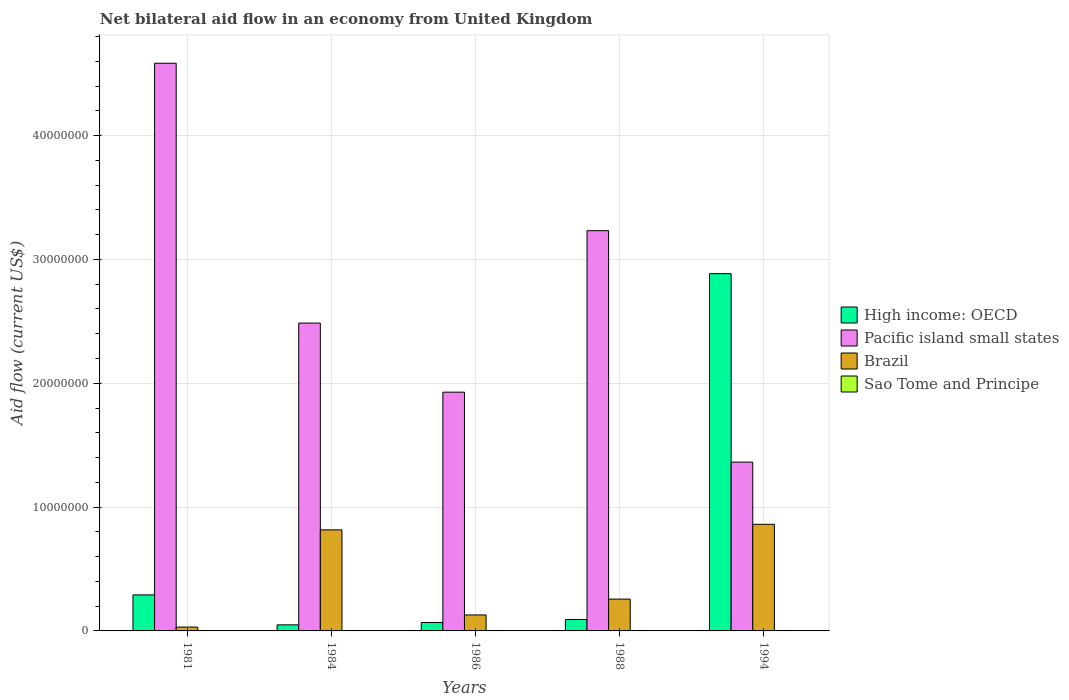How many different coloured bars are there?
Your answer should be compact. 4. How many groups of bars are there?
Provide a short and direct response. 5. Are the number of bars on each tick of the X-axis equal?
Keep it short and to the point. Yes. How many bars are there on the 5th tick from the right?
Keep it short and to the point. 4. What is the label of the 4th group of bars from the left?
Your response must be concise. 1988. In how many cases, is the number of bars for a given year not equal to the number of legend labels?
Give a very brief answer. 0. What is the net bilateral aid flow in High income: OECD in 1984?
Your answer should be compact. 4.90e+05. Across all years, what is the maximum net bilateral aid flow in High income: OECD?
Keep it short and to the point. 2.88e+07. Across all years, what is the minimum net bilateral aid flow in High income: OECD?
Your response must be concise. 4.90e+05. In which year was the net bilateral aid flow in Sao Tome and Principe minimum?
Provide a short and direct response. 1981. What is the total net bilateral aid flow in Pacific island small states in the graph?
Your answer should be compact. 1.36e+08. What is the difference between the net bilateral aid flow in Brazil in 1981 and that in 1988?
Offer a very short reply. -2.26e+06. What is the difference between the net bilateral aid flow in High income: OECD in 1981 and the net bilateral aid flow in Pacific island small states in 1984?
Give a very brief answer. -2.20e+07. What is the average net bilateral aid flow in High income: OECD per year?
Ensure brevity in your answer.  6.77e+06. In the year 1981, what is the difference between the net bilateral aid flow in Sao Tome and Principe and net bilateral aid flow in High income: OECD?
Give a very brief answer. -2.90e+06. In how many years, is the net bilateral aid flow in Brazil greater than 44000000 US$?
Offer a very short reply. 0. What is the ratio of the net bilateral aid flow in Brazil in 1988 to that in 1994?
Offer a very short reply. 0.3. Is the net bilateral aid flow in Sao Tome and Principe in 1981 less than that in 1986?
Make the answer very short. No. What is the difference between the highest and the second highest net bilateral aid flow in Pacific island small states?
Offer a terse response. 1.35e+07. What is the difference between the highest and the lowest net bilateral aid flow in Sao Tome and Principe?
Keep it short and to the point. 2.00e+04. Is it the case that in every year, the sum of the net bilateral aid flow in High income: OECD and net bilateral aid flow in Pacific island small states is greater than the sum of net bilateral aid flow in Brazil and net bilateral aid flow in Sao Tome and Principe?
Offer a very short reply. Yes. What does the 1st bar from the left in 1988 represents?
Ensure brevity in your answer.  High income: OECD. What does the 4th bar from the right in 1994 represents?
Offer a terse response. High income: OECD. Are all the bars in the graph horizontal?
Give a very brief answer. No. Does the graph contain grids?
Provide a short and direct response. Yes. How are the legend labels stacked?
Provide a succinct answer. Vertical. What is the title of the graph?
Keep it short and to the point. Net bilateral aid flow in an economy from United Kingdom. What is the label or title of the X-axis?
Offer a terse response. Years. What is the label or title of the Y-axis?
Provide a short and direct response. Aid flow (current US$). What is the Aid flow (current US$) in High income: OECD in 1981?
Give a very brief answer. 2.91e+06. What is the Aid flow (current US$) of Pacific island small states in 1981?
Offer a very short reply. 4.58e+07. What is the Aid flow (current US$) in Sao Tome and Principe in 1981?
Your answer should be compact. 10000. What is the Aid flow (current US$) in Pacific island small states in 1984?
Keep it short and to the point. 2.49e+07. What is the Aid flow (current US$) of Brazil in 1984?
Give a very brief answer. 8.16e+06. What is the Aid flow (current US$) of High income: OECD in 1986?
Your response must be concise. 6.80e+05. What is the Aid flow (current US$) of Pacific island small states in 1986?
Ensure brevity in your answer.  1.93e+07. What is the Aid flow (current US$) of Brazil in 1986?
Your response must be concise. 1.29e+06. What is the Aid flow (current US$) of High income: OECD in 1988?
Your answer should be compact. 9.20e+05. What is the Aid flow (current US$) in Pacific island small states in 1988?
Ensure brevity in your answer.  3.23e+07. What is the Aid flow (current US$) of Brazil in 1988?
Make the answer very short. 2.57e+06. What is the Aid flow (current US$) of High income: OECD in 1994?
Your answer should be very brief. 2.88e+07. What is the Aid flow (current US$) of Pacific island small states in 1994?
Your answer should be compact. 1.36e+07. What is the Aid flow (current US$) in Brazil in 1994?
Give a very brief answer. 8.61e+06. What is the Aid flow (current US$) of Sao Tome and Principe in 1994?
Make the answer very short. 10000. Across all years, what is the maximum Aid flow (current US$) in High income: OECD?
Provide a succinct answer. 2.88e+07. Across all years, what is the maximum Aid flow (current US$) in Pacific island small states?
Give a very brief answer. 4.58e+07. Across all years, what is the maximum Aid flow (current US$) in Brazil?
Give a very brief answer. 8.61e+06. Across all years, what is the minimum Aid flow (current US$) in Pacific island small states?
Your answer should be compact. 1.36e+07. What is the total Aid flow (current US$) of High income: OECD in the graph?
Ensure brevity in your answer.  3.38e+07. What is the total Aid flow (current US$) of Pacific island small states in the graph?
Your response must be concise. 1.36e+08. What is the total Aid flow (current US$) in Brazil in the graph?
Give a very brief answer. 2.09e+07. What is the total Aid flow (current US$) of Sao Tome and Principe in the graph?
Make the answer very short. 9.00e+04. What is the difference between the Aid flow (current US$) of High income: OECD in 1981 and that in 1984?
Your answer should be compact. 2.42e+06. What is the difference between the Aid flow (current US$) in Pacific island small states in 1981 and that in 1984?
Offer a terse response. 2.10e+07. What is the difference between the Aid flow (current US$) of Brazil in 1981 and that in 1984?
Provide a succinct answer. -7.85e+06. What is the difference between the Aid flow (current US$) in High income: OECD in 1981 and that in 1986?
Your answer should be very brief. 2.23e+06. What is the difference between the Aid flow (current US$) in Pacific island small states in 1981 and that in 1986?
Give a very brief answer. 2.66e+07. What is the difference between the Aid flow (current US$) in Brazil in 1981 and that in 1986?
Make the answer very short. -9.80e+05. What is the difference between the Aid flow (current US$) in High income: OECD in 1981 and that in 1988?
Give a very brief answer. 1.99e+06. What is the difference between the Aid flow (current US$) in Pacific island small states in 1981 and that in 1988?
Your response must be concise. 1.35e+07. What is the difference between the Aid flow (current US$) of Brazil in 1981 and that in 1988?
Your response must be concise. -2.26e+06. What is the difference between the Aid flow (current US$) in High income: OECD in 1981 and that in 1994?
Your answer should be compact. -2.59e+07. What is the difference between the Aid flow (current US$) in Pacific island small states in 1981 and that in 1994?
Your answer should be very brief. 3.22e+07. What is the difference between the Aid flow (current US$) of Brazil in 1981 and that in 1994?
Offer a terse response. -8.30e+06. What is the difference between the Aid flow (current US$) in High income: OECD in 1984 and that in 1986?
Offer a terse response. -1.90e+05. What is the difference between the Aid flow (current US$) in Pacific island small states in 1984 and that in 1986?
Provide a short and direct response. 5.58e+06. What is the difference between the Aid flow (current US$) of Brazil in 1984 and that in 1986?
Keep it short and to the point. 6.87e+06. What is the difference between the Aid flow (current US$) of High income: OECD in 1984 and that in 1988?
Your answer should be compact. -4.30e+05. What is the difference between the Aid flow (current US$) in Pacific island small states in 1984 and that in 1988?
Make the answer very short. -7.46e+06. What is the difference between the Aid flow (current US$) in Brazil in 1984 and that in 1988?
Your answer should be very brief. 5.59e+06. What is the difference between the Aid flow (current US$) of High income: OECD in 1984 and that in 1994?
Keep it short and to the point. -2.84e+07. What is the difference between the Aid flow (current US$) in Pacific island small states in 1984 and that in 1994?
Keep it short and to the point. 1.12e+07. What is the difference between the Aid flow (current US$) in Brazil in 1984 and that in 1994?
Provide a short and direct response. -4.50e+05. What is the difference between the Aid flow (current US$) in Sao Tome and Principe in 1984 and that in 1994?
Offer a terse response. 2.00e+04. What is the difference between the Aid flow (current US$) in Pacific island small states in 1986 and that in 1988?
Make the answer very short. -1.30e+07. What is the difference between the Aid flow (current US$) of Brazil in 1986 and that in 1988?
Keep it short and to the point. -1.28e+06. What is the difference between the Aid flow (current US$) in High income: OECD in 1986 and that in 1994?
Provide a short and direct response. -2.82e+07. What is the difference between the Aid flow (current US$) of Pacific island small states in 1986 and that in 1994?
Ensure brevity in your answer.  5.65e+06. What is the difference between the Aid flow (current US$) of Brazil in 1986 and that in 1994?
Your answer should be compact. -7.32e+06. What is the difference between the Aid flow (current US$) in High income: OECD in 1988 and that in 1994?
Your answer should be very brief. -2.79e+07. What is the difference between the Aid flow (current US$) in Pacific island small states in 1988 and that in 1994?
Offer a very short reply. 1.87e+07. What is the difference between the Aid flow (current US$) in Brazil in 1988 and that in 1994?
Offer a very short reply. -6.04e+06. What is the difference between the Aid flow (current US$) in Sao Tome and Principe in 1988 and that in 1994?
Your answer should be very brief. 2.00e+04. What is the difference between the Aid flow (current US$) in High income: OECD in 1981 and the Aid flow (current US$) in Pacific island small states in 1984?
Provide a succinct answer. -2.20e+07. What is the difference between the Aid flow (current US$) of High income: OECD in 1981 and the Aid flow (current US$) of Brazil in 1984?
Your response must be concise. -5.25e+06. What is the difference between the Aid flow (current US$) of High income: OECD in 1981 and the Aid flow (current US$) of Sao Tome and Principe in 1984?
Keep it short and to the point. 2.88e+06. What is the difference between the Aid flow (current US$) in Pacific island small states in 1981 and the Aid flow (current US$) in Brazil in 1984?
Your answer should be compact. 3.77e+07. What is the difference between the Aid flow (current US$) of Pacific island small states in 1981 and the Aid flow (current US$) of Sao Tome and Principe in 1984?
Your response must be concise. 4.58e+07. What is the difference between the Aid flow (current US$) in High income: OECD in 1981 and the Aid flow (current US$) in Pacific island small states in 1986?
Make the answer very short. -1.64e+07. What is the difference between the Aid flow (current US$) of High income: OECD in 1981 and the Aid flow (current US$) of Brazil in 1986?
Offer a terse response. 1.62e+06. What is the difference between the Aid flow (current US$) of High income: OECD in 1981 and the Aid flow (current US$) of Sao Tome and Principe in 1986?
Provide a succinct answer. 2.90e+06. What is the difference between the Aid flow (current US$) in Pacific island small states in 1981 and the Aid flow (current US$) in Brazil in 1986?
Keep it short and to the point. 4.46e+07. What is the difference between the Aid flow (current US$) of Pacific island small states in 1981 and the Aid flow (current US$) of Sao Tome and Principe in 1986?
Make the answer very short. 4.58e+07. What is the difference between the Aid flow (current US$) of High income: OECD in 1981 and the Aid flow (current US$) of Pacific island small states in 1988?
Make the answer very short. -2.94e+07. What is the difference between the Aid flow (current US$) of High income: OECD in 1981 and the Aid flow (current US$) of Sao Tome and Principe in 1988?
Give a very brief answer. 2.88e+06. What is the difference between the Aid flow (current US$) of Pacific island small states in 1981 and the Aid flow (current US$) of Brazil in 1988?
Your answer should be compact. 4.33e+07. What is the difference between the Aid flow (current US$) of Pacific island small states in 1981 and the Aid flow (current US$) of Sao Tome and Principe in 1988?
Offer a terse response. 4.58e+07. What is the difference between the Aid flow (current US$) in Brazil in 1981 and the Aid flow (current US$) in Sao Tome and Principe in 1988?
Your response must be concise. 2.80e+05. What is the difference between the Aid flow (current US$) in High income: OECD in 1981 and the Aid flow (current US$) in Pacific island small states in 1994?
Provide a succinct answer. -1.07e+07. What is the difference between the Aid flow (current US$) in High income: OECD in 1981 and the Aid flow (current US$) in Brazil in 1994?
Provide a short and direct response. -5.70e+06. What is the difference between the Aid flow (current US$) in High income: OECD in 1981 and the Aid flow (current US$) in Sao Tome and Principe in 1994?
Provide a short and direct response. 2.90e+06. What is the difference between the Aid flow (current US$) of Pacific island small states in 1981 and the Aid flow (current US$) of Brazil in 1994?
Make the answer very short. 3.72e+07. What is the difference between the Aid flow (current US$) of Pacific island small states in 1981 and the Aid flow (current US$) of Sao Tome and Principe in 1994?
Your response must be concise. 4.58e+07. What is the difference between the Aid flow (current US$) in Brazil in 1981 and the Aid flow (current US$) in Sao Tome and Principe in 1994?
Keep it short and to the point. 3.00e+05. What is the difference between the Aid flow (current US$) in High income: OECD in 1984 and the Aid flow (current US$) in Pacific island small states in 1986?
Offer a terse response. -1.88e+07. What is the difference between the Aid flow (current US$) of High income: OECD in 1984 and the Aid flow (current US$) of Brazil in 1986?
Offer a very short reply. -8.00e+05. What is the difference between the Aid flow (current US$) of Pacific island small states in 1984 and the Aid flow (current US$) of Brazil in 1986?
Ensure brevity in your answer.  2.36e+07. What is the difference between the Aid flow (current US$) in Pacific island small states in 1984 and the Aid flow (current US$) in Sao Tome and Principe in 1986?
Provide a short and direct response. 2.48e+07. What is the difference between the Aid flow (current US$) of Brazil in 1984 and the Aid flow (current US$) of Sao Tome and Principe in 1986?
Offer a terse response. 8.15e+06. What is the difference between the Aid flow (current US$) of High income: OECD in 1984 and the Aid flow (current US$) of Pacific island small states in 1988?
Keep it short and to the point. -3.18e+07. What is the difference between the Aid flow (current US$) of High income: OECD in 1984 and the Aid flow (current US$) of Brazil in 1988?
Give a very brief answer. -2.08e+06. What is the difference between the Aid flow (current US$) of High income: OECD in 1984 and the Aid flow (current US$) of Sao Tome and Principe in 1988?
Your answer should be very brief. 4.60e+05. What is the difference between the Aid flow (current US$) of Pacific island small states in 1984 and the Aid flow (current US$) of Brazil in 1988?
Your answer should be compact. 2.23e+07. What is the difference between the Aid flow (current US$) of Pacific island small states in 1984 and the Aid flow (current US$) of Sao Tome and Principe in 1988?
Your answer should be compact. 2.48e+07. What is the difference between the Aid flow (current US$) in Brazil in 1984 and the Aid flow (current US$) in Sao Tome and Principe in 1988?
Ensure brevity in your answer.  8.13e+06. What is the difference between the Aid flow (current US$) in High income: OECD in 1984 and the Aid flow (current US$) in Pacific island small states in 1994?
Give a very brief answer. -1.31e+07. What is the difference between the Aid flow (current US$) in High income: OECD in 1984 and the Aid flow (current US$) in Brazil in 1994?
Ensure brevity in your answer.  -8.12e+06. What is the difference between the Aid flow (current US$) of Pacific island small states in 1984 and the Aid flow (current US$) of Brazil in 1994?
Your answer should be compact. 1.62e+07. What is the difference between the Aid flow (current US$) in Pacific island small states in 1984 and the Aid flow (current US$) in Sao Tome and Principe in 1994?
Your answer should be very brief. 2.48e+07. What is the difference between the Aid flow (current US$) in Brazil in 1984 and the Aid flow (current US$) in Sao Tome and Principe in 1994?
Your response must be concise. 8.15e+06. What is the difference between the Aid flow (current US$) of High income: OECD in 1986 and the Aid flow (current US$) of Pacific island small states in 1988?
Make the answer very short. -3.16e+07. What is the difference between the Aid flow (current US$) in High income: OECD in 1986 and the Aid flow (current US$) in Brazil in 1988?
Provide a succinct answer. -1.89e+06. What is the difference between the Aid flow (current US$) in High income: OECD in 1986 and the Aid flow (current US$) in Sao Tome and Principe in 1988?
Make the answer very short. 6.50e+05. What is the difference between the Aid flow (current US$) of Pacific island small states in 1986 and the Aid flow (current US$) of Brazil in 1988?
Keep it short and to the point. 1.67e+07. What is the difference between the Aid flow (current US$) in Pacific island small states in 1986 and the Aid flow (current US$) in Sao Tome and Principe in 1988?
Offer a terse response. 1.92e+07. What is the difference between the Aid flow (current US$) in Brazil in 1986 and the Aid flow (current US$) in Sao Tome and Principe in 1988?
Your response must be concise. 1.26e+06. What is the difference between the Aid flow (current US$) of High income: OECD in 1986 and the Aid flow (current US$) of Pacific island small states in 1994?
Make the answer very short. -1.30e+07. What is the difference between the Aid flow (current US$) in High income: OECD in 1986 and the Aid flow (current US$) in Brazil in 1994?
Keep it short and to the point. -7.93e+06. What is the difference between the Aid flow (current US$) in High income: OECD in 1986 and the Aid flow (current US$) in Sao Tome and Principe in 1994?
Provide a succinct answer. 6.70e+05. What is the difference between the Aid flow (current US$) of Pacific island small states in 1986 and the Aid flow (current US$) of Brazil in 1994?
Make the answer very short. 1.07e+07. What is the difference between the Aid flow (current US$) of Pacific island small states in 1986 and the Aid flow (current US$) of Sao Tome and Principe in 1994?
Make the answer very short. 1.93e+07. What is the difference between the Aid flow (current US$) in Brazil in 1986 and the Aid flow (current US$) in Sao Tome and Principe in 1994?
Your answer should be very brief. 1.28e+06. What is the difference between the Aid flow (current US$) in High income: OECD in 1988 and the Aid flow (current US$) in Pacific island small states in 1994?
Make the answer very short. -1.27e+07. What is the difference between the Aid flow (current US$) of High income: OECD in 1988 and the Aid flow (current US$) of Brazil in 1994?
Provide a succinct answer. -7.69e+06. What is the difference between the Aid flow (current US$) of High income: OECD in 1988 and the Aid flow (current US$) of Sao Tome and Principe in 1994?
Your response must be concise. 9.10e+05. What is the difference between the Aid flow (current US$) in Pacific island small states in 1988 and the Aid flow (current US$) in Brazil in 1994?
Provide a succinct answer. 2.37e+07. What is the difference between the Aid flow (current US$) of Pacific island small states in 1988 and the Aid flow (current US$) of Sao Tome and Principe in 1994?
Your response must be concise. 3.23e+07. What is the difference between the Aid flow (current US$) in Brazil in 1988 and the Aid flow (current US$) in Sao Tome and Principe in 1994?
Offer a very short reply. 2.56e+06. What is the average Aid flow (current US$) in High income: OECD per year?
Offer a terse response. 6.77e+06. What is the average Aid flow (current US$) of Pacific island small states per year?
Keep it short and to the point. 2.72e+07. What is the average Aid flow (current US$) of Brazil per year?
Your response must be concise. 4.19e+06. What is the average Aid flow (current US$) of Sao Tome and Principe per year?
Offer a terse response. 1.80e+04. In the year 1981, what is the difference between the Aid flow (current US$) of High income: OECD and Aid flow (current US$) of Pacific island small states?
Provide a succinct answer. -4.29e+07. In the year 1981, what is the difference between the Aid flow (current US$) in High income: OECD and Aid flow (current US$) in Brazil?
Your answer should be compact. 2.60e+06. In the year 1981, what is the difference between the Aid flow (current US$) of High income: OECD and Aid flow (current US$) of Sao Tome and Principe?
Ensure brevity in your answer.  2.90e+06. In the year 1981, what is the difference between the Aid flow (current US$) in Pacific island small states and Aid flow (current US$) in Brazil?
Make the answer very short. 4.55e+07. In the year 1981, what is the difference between the Aid flow (current US$) of Pacific island small states and Aid flow (current US$) of Sao Tome and Principe?
Make the answer very short. 4.58e+07. In the year 1984, what is the difference between the Aid flow (current US$) of High income: OECD and Aid flow (current US$) of Pacific island small states?
Offer a very short reply. -2.44e+07. In the year 1984, what is the difference between the Aid flow (current US$) in High income: OECD and Aid flow (current US$) in Brazil?
Ensure brevity in your answer.  -7.67e+06. In the year 1984, what is the difference between the Aid flow (current US$) of Pacific island small states and Aid flow (current US$) of Brazil?
Your answer should be compact. 1.67e+07. In the year 1984, what is the difference between the Aid flow (current US$) in Pacific island small states and Aid flow (current US$) in Sao Tome and Principe?
Provide a succinct answer. 2.48e+07. In the year 1984, what is the difference between the Aid flow (current US$) in Brazil and Aid flow (current US$) in Sao Tome and Principe?
Provide a short and direct response. 8.13e+06. In the year 1986, what is the difference between the Aid flow (current US$) in High income: OECD and Aid flow (current US$) in Pacific island small states?
Offer a very short reply. -1.86e+07. In the year 1986, what is the difference between the Aid flow (current US$) in High income: OECD and Aid flow (current US$) in Brazil?
Offer a very short reply. -6.10e+05. In the year 1986, what is the difference between the Aid flow (current US$) in High income: OECD and Aid flow (current US$) in Sao Tome and Principe?
Your answer should be compact. 6.70e+05. In the year 1986, what is the difference between the Aid flow (current US$) of Pacific island small states and Aid flow (current US$) of Brazil?
Make the answer very short. 1.80e+07. In the year 1986, what is the difference between the Aid flow (current US$) of Pacific island small states and Aid flow (current US$) of Sao Tome and Principe?
Offer a very short reply. 1.93e+07. In the year 1986, what is the difference between the Aid flow (current US$) of Brazil and Aid flow (current US$) of Sao Tome and Principe?
Your response must be concise. 1.28e+06. In the year 1988, what is the difference between the Aid flow (current US$) in High income: OECD and Aid flow (current US$) in Pacific island small states?
Your answer should be compact. -3.14e+07. In the year 1988, what is the difference between the Aid flow (current US$) of High income: OECD and Aid flow (current US$) of Brazil?
Provide a short and direct response. -1.65e+06. In the year 1988, what is the difference between the Aid flow (current US$) of High income: OECD and Aid flow (current US$) of Sao Tome and Principe?
Offer a terse response. 8.90e+05. In the year 1988, what is the difference between the Aid flow (current US$) of Pacific island small states and Aid flow (current US$) of Brazil?
Give a very brief answer. 2.98e+07. In the year 1988, what is the difference between the Aid flow (current US$) in Pacific island small states and Aid flow (current US$) in Sao Tome and Principe?
Ensure brevity in your answer.  3.23e+07. In the year 1988, what is the difference between the Aid flow (current US$) of Brazil and Aid flow (current US$) of Sao Tome and Principe?
Your answer should be compact. 2.54e+06. In the year 1994, what is the difference between the Aid flow (current US$) of High income: OECD and Aid flow (current US$) of Pacific island small states?
Give a very brief answer. 1.52e+07. In the year 1994, what is the difference between the Aid flow (current US$) in High income: OECD and Aid flow (current US$) in Brazil?
Ensure brevity in your answer.  2.02e+07. In the year 1994, what is the difference between the Aid flow (current US$) in High income: OECD and Aid flow (current US$) in Sao Tome and Principe?
Your answer should be compact. 2.88e+07. In the year 1994, what is the difference between the Aid flow (current US$) in Pacific island small states and Aid flow (current US$) in Brazil?
Keep it short and to the point. 5.02e+06. In the year 1994, what is the difference between the Aid flow (current US$) in Pacific island small states and Aid flow (current US$) in Sao Tome and Principe?
Offer a terse response. 1.36e+07. In the year 1994, what is the difference between the Aid flow (current US$) of Brazil and Aid flow (current US$) of Sao Tome and Principe?
Your answer should be compact. 8.60e+06. What is the ratio of the Aid flow (current US$) in High income: OECD in 1981 to that in 1984?
Keep it short and to the point. 5.94. What is the ratio of the Aid flow (current US$) in Pacific island small states in 1981 to that in 1984?
Ensure brevity in your answer.  1.84. What is the ratio of the Aid flow (current US$) of Brazil in 1981 to that in 1984?
Provide a succinct answer. 0.04. What is the ratio of the Aid flow (current US$) in Sao Tome and Principe in 1981 to that in 1984?
Offer a very short reply. 0.33. What is the ratio of the Aid flow (current US$) in High income: OECD in 1981 to that in 1986?
Keep it short and to the point. 4.28. What is the ratio of the Aid flow (current US$) in Pacific island small states in 1981 to that in 1986?
Provide a short and direct response. 2.38. What is the ratio of the Aid flow (current US$) in Brazil in 1981 to that in 1986?
Provide a short and direct response. 0.24. What is the ratio of the Aid flow (current US$) in High income: OECD in 1981 to that in 1988?
Ensure brevity in your answer.  3.16. What is the ratio of the Aid flow (current US$) in Pacific island small states in 1981 to that in 1988?
Your answer should be compact. 1.42. What is the ratio of the Aid flow (current US$) in Brazil in 1981 to that in 1988?
Keep it short and to the point. 0.12. What is the ratio of the Aid flow (current US$) in Sao Tome and Principe in 1981 to that in 1988?
Offer a terse response. 0.33. What is the ratio of the Aid flow (current US$) in High income: OECD in 1981 to that in 1994?
Offer a terse response. 0.1. What is the ratio of the Aid flow (current US$) in Pacific island small states in 1981 to that in 1994?
Provide a succinct answer. 3.36. What is the ratio of the Aid flow (current US$) of Brazil in 1981 to that in 1994?
Ensure brevity in your answer.  0.04. What is the ratio of the Aid flow (current US$) in Sao Tome and Principe in 1981 to that in 1994?
Your answer should be very brief. 1. What is the ratio of the Aid flow (current US$) in High income: OECD in 1984 to that in 1986?
Your answer should be compact. 0.72. What is the ratio of the Aid flow (current US$) of Pacific island small states in 1984 to that in 1986?
Your answer should be very brief. 1.29. What is the ratio of the Aid flow (current US$) in Brazil in 1984 to that in 1986?
Ensure brevity in your answer.  6.33. What is the ratio of the Aid flow (current US$) in Sao Tome and Principe in 1984 to that in 1986?
Provide a short and direct response. 3. What is the ratio of the Aid flow (current US$) of High income: OECD in 1984 to that in 1988?
Ensure brevity in your answer.  0.53. What is the ratio of the Aid flow (current US$) in Pacific island small states in 1984 to that in 1988?
Provide a succinct answer. 0.77. What is the ratio of the Aid flow (current US$) of Brazil in 1984 to that in 1988?
Your answer should be compact. 3.18. What is the ratio of the Aid flow (current US$) in Sao Tome and Principe in 1984 to that in 1988?
Provide a short and direct response. 1. What is the ratio of the Aid flow (current US$) of High income: OECD in 1984 to that in 1994?
Your answer should be compact. 0.02. What is the ratio of the Aid flow (current US$) of Pacific island small states in 1984 to that in 1994?
Your answer should be very brief. 1.82. What is the ratio of the Aid flow (current US$) in Brazil in 1984 to that in 1994?
Provide a succinct answer. 0.95. What is the ratio of the Aid flow (current US$) of High income: OECD in 1986 to that in 1988?
Offer a very short reply. 0.74. What is the ratio of the Aid flow (current US$) in Pacific island small states in 1986 to that in 1988?
Your response must be concise. 0.6. What is the ratio of the Aid flow (current US$) in Brazil in 1986 to that in 1988?
Provide a succinct answer. 0.5. What is the ratio of the Aid flow (current US$) in Sao Tome and Principe in 1986 to that in 1988?
Ensure brevity in your answer.  0.33. What is the ratio of the Aid flow (current US$) in High income: OECD in 1986 to that in 1994?
Keep it short and to the point. 0.02. What is the ratio of the Aid flow (current US$) in Pacific island small states in 1986 to that in 1994?
Keep it short and to the point. 1.41. What is the ratio of the Aid flow (current US$) in Brazil in 1986 to that in 1994?
Provide a short and direct response. 0.15. What is the ratio of the Aid flow (current US$) of Sao Tome and Principe in 1986 to that in 1994?
Offer a terse response. 1. What is the ratio of the Aid flow (current US$) of High income: OECD in 1988 to that in 1994?
Keep it short and to the point. 0.03. What is the ratio of the Aid flow (current US$) in Pacific island small states in 1988 to that in 1994?
Your response must be concise. 2.37. What is the ratio of the Aid flow (current US$) of Brazil in 1988 to that in 1994?
Offer a terse response. 0.3. What is the difference between the highest and the second highest Aid flow (current US$) in High income: OECD?
Provide a succinct answer. 2.59e+07. What is the difference between the highest and the second highest Aid flow (current US$) in Pacific island small states?
Your answer should be compact. 1.35e+07. What is the difference between the highest and the second highest Aid flow (current US$) in Brazil?
Ensure brevity in your answer.  4.50e+05. What is the difference between the highest and the second highest Aid flow (current US$) of Sao Tome and Principe?
Provide a succinct answer. 0. What is the difference between the highest and the lowest Aid flow (current US$) of High income: OECD?
Your response must be concise. 2.84e+07. What is the difference between the highest and the lowest Aid flow (current US$) of Pacific island small states?
Offer a very short reply. 3.22e+07. What is the difference between the highest and the lowest Aid flow (current US$) of Brazil?
Make the answer very short. 8.30e+06. 